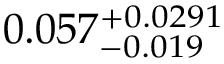<formula> <loc_0><loc_0><loc_500><loc_500>0 . 0 5 7 _ { - 0 . 0 1 9 } ^ { + 0 . 0 2 9 1 }</formula> 